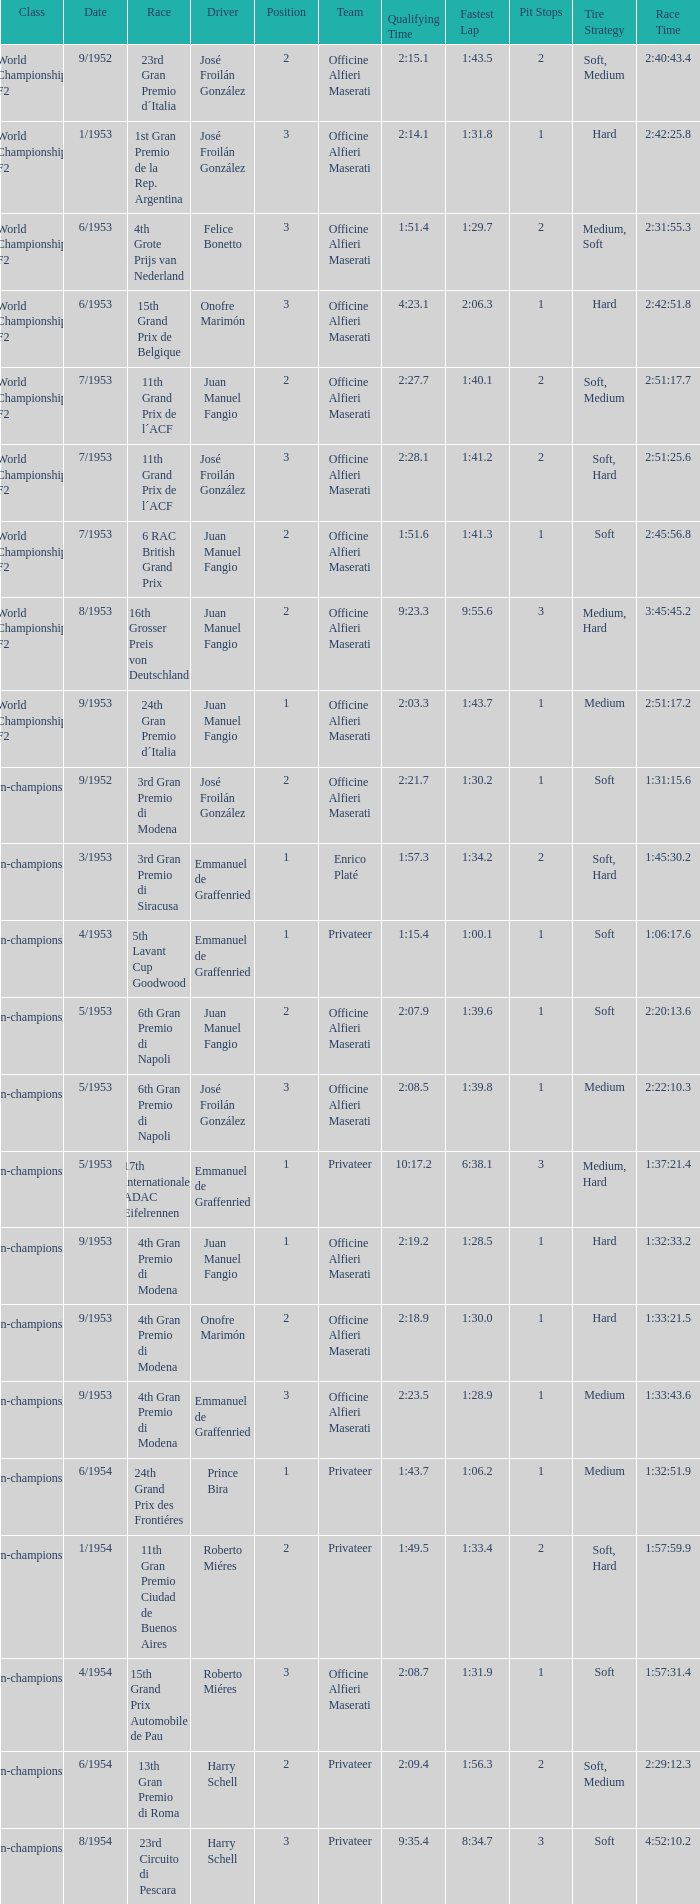What date has the class of non-championship f2 as well as a driver name josé froilán gonzález that has a position larger than 2? 5/1953. 